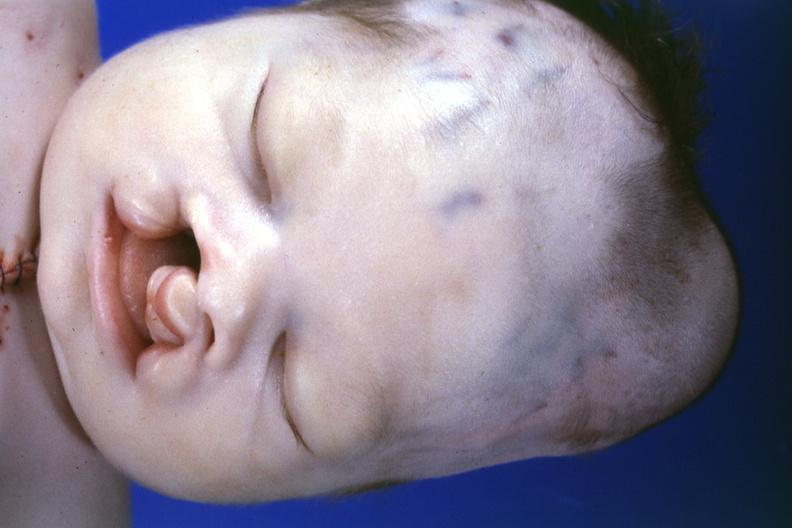what is present?
Answer the question using a single word or phrase. Cephalohematoma 